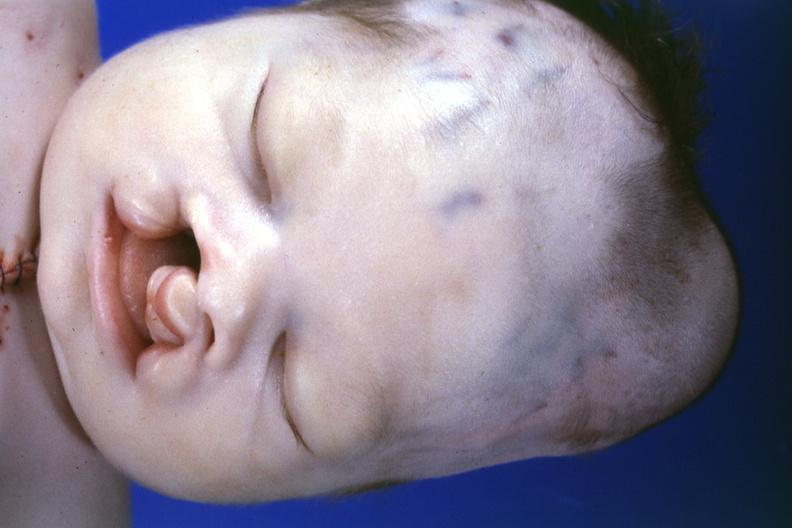what is present?
Answer the question using a single word or phrase. Cephalohematoma 